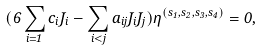Convert formula to latex. <formula><loc_0><loc_0><loc_500><loc_500>( 6 \sum _ { i = 1 } c _ { i } J _ { i } - \sum _ { i < j } a _ { i j } J _ { i } J _ { j } ) \eta ^ { ( s _ { 1 } , s _ { 2 } , s _ { 3 } , s _ { 4 } ) } = 0 ,</formula> 